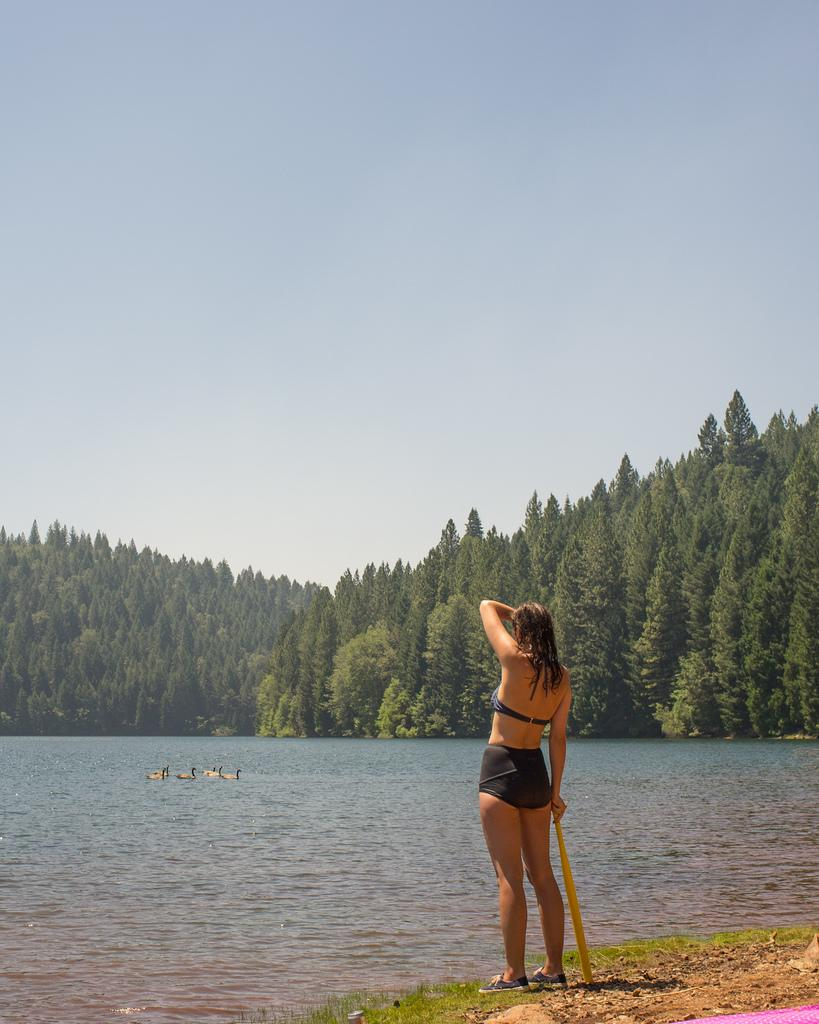What types of terrain are visible in the foreground of the image? There is grass and sand in the foreground of the image. Can you describe the person in the image? There is a person standing in the image. What is visible in the water in the image? There are birds in the water. What can be seen in the background of the image? There are trees in the background of the image. What part of the natural environment is visible in the image? The sky is visible in the image. What type of teaching is the person conducting in the image? There is no indication of teaching in the image; the person is simply standing. How many bears are visible in the image? There are no bears present in the image. 